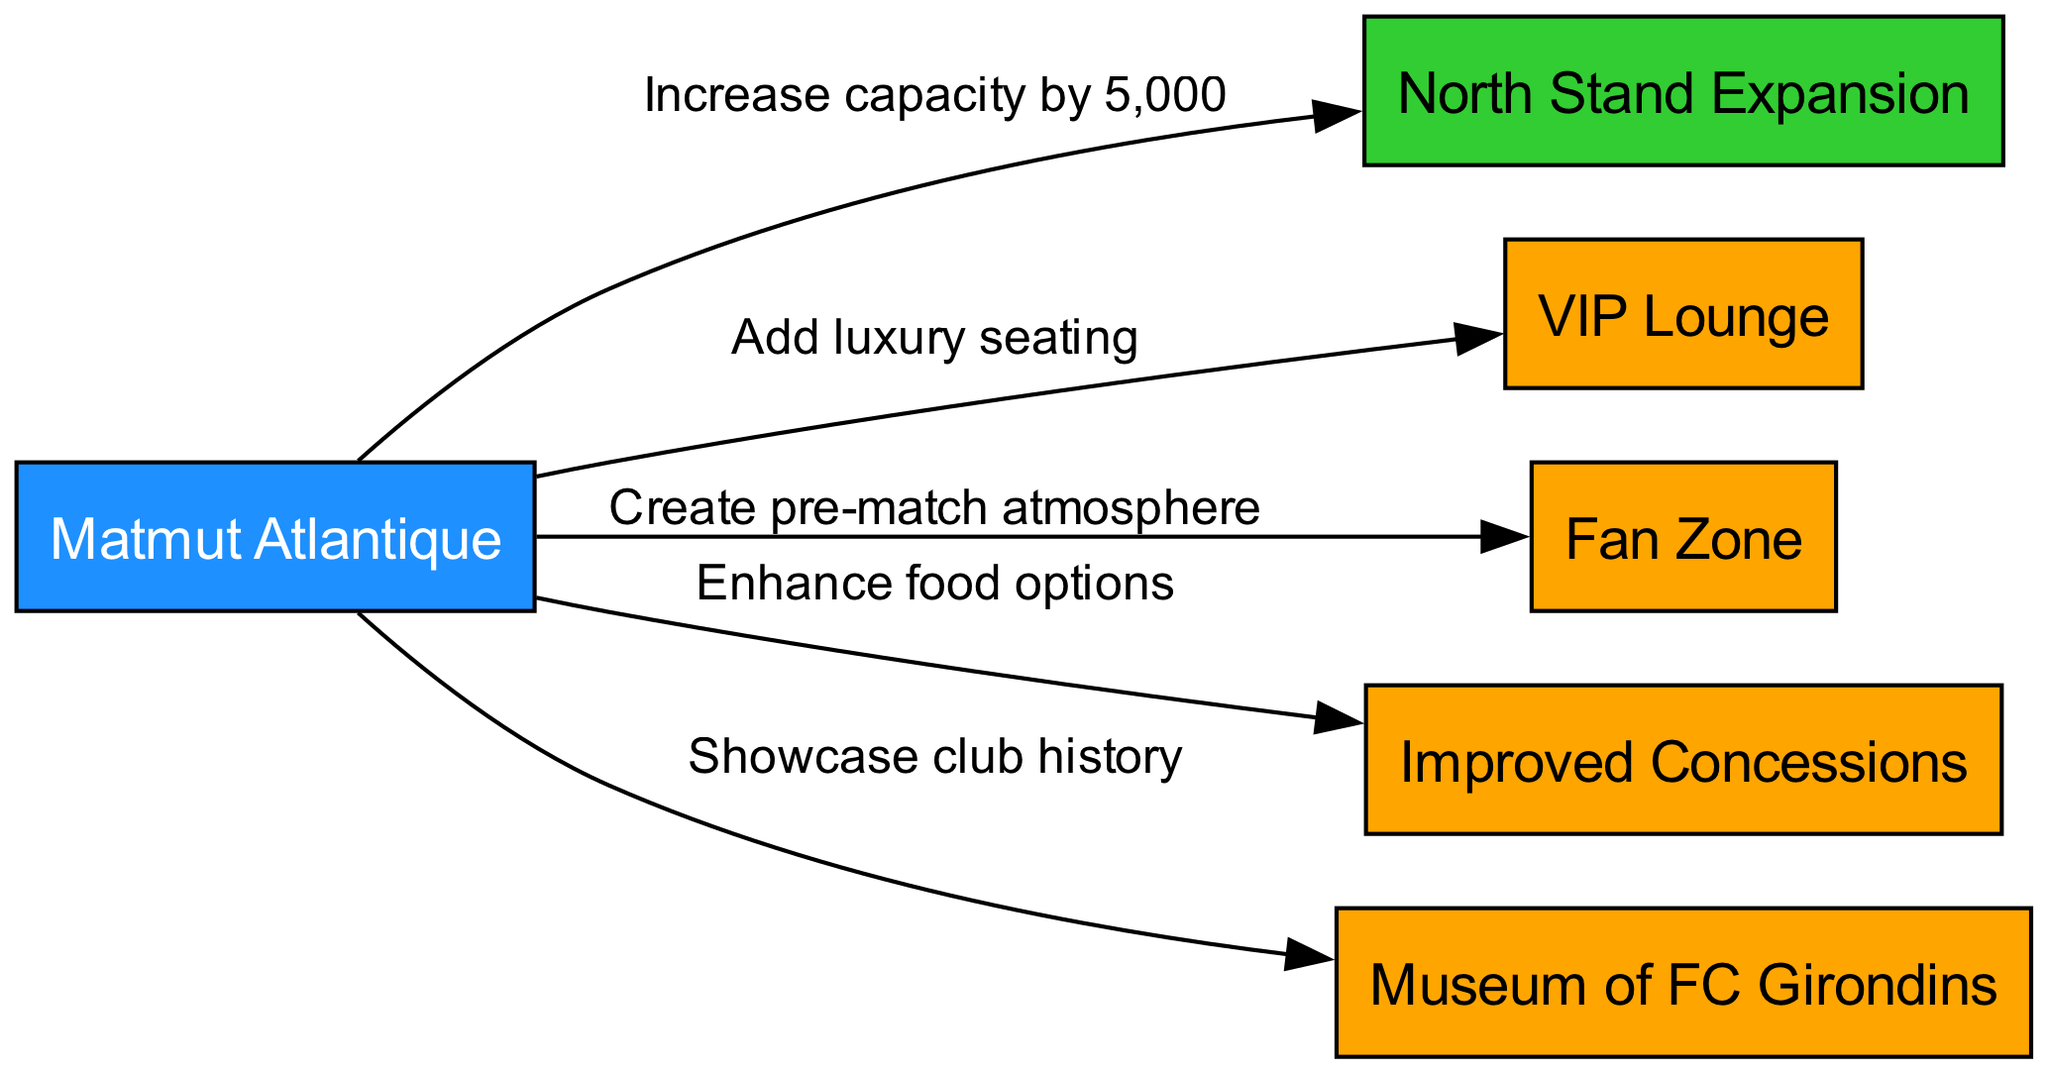What is the main facility added to Matmut Atlantique? The diagram indicates that the main facility added is the VIP Lounge, as it is directly linked to the stadium node and labeled as a facility.
Answer: VIP Lounge How many new seating sections are proposed? The diagram shows one specific node dedicated to the North Stand Expansion, indicating the addition of one new seating section.
Answer: One What is the total increase in capacity from the expansion? The diagram specifies that the North Stand Expansion will increase capacity by 5,000, providing a clear quantitative measure of the expansion's effect.
Answer: 5,000 What type of atmosphere is being created in the Fan Zone? The diagram describes the relationship between the stadium and Fan Zone as a "Create pre-match atmosphere," indicating the specific function intended for this facility.
Answer: Pre-match atmosphere What key feature showcases the history of FC Girondins? The diagram labels the Museum of FC Girondins as a facility directly connected to the stadium, clearly identifying its role in showcasing the club's history.
Answer: Museum of FC Girondins Which edges indicate enhanced food options? The diagram shows an edge from the stadium to Improved Concessions labeled "Enhance food options," explicitly associating this edge with food improvements.
Answer: Enhanced food options What color represents the seating node in the diagram? The North Stand Expansion node, representing seating, is filled with a green color (#32CD32) as indicated by the custom node styles in the diagram.
Answer: Green How are the luxury seating arrangements linked to the stadium? The diagram illustrates that the luxury seating is labeled "Add luxury seating" and is connected directly from the stadium node, indicating the enhancement in seating quality.
Answer: Add luxury seating What type of node represents the North Stand Expansion? In the diagram, the North Stand Expansion is categorized as a "seating" type node, which is visually distinct from facility type nodes.
Answer: Seating 